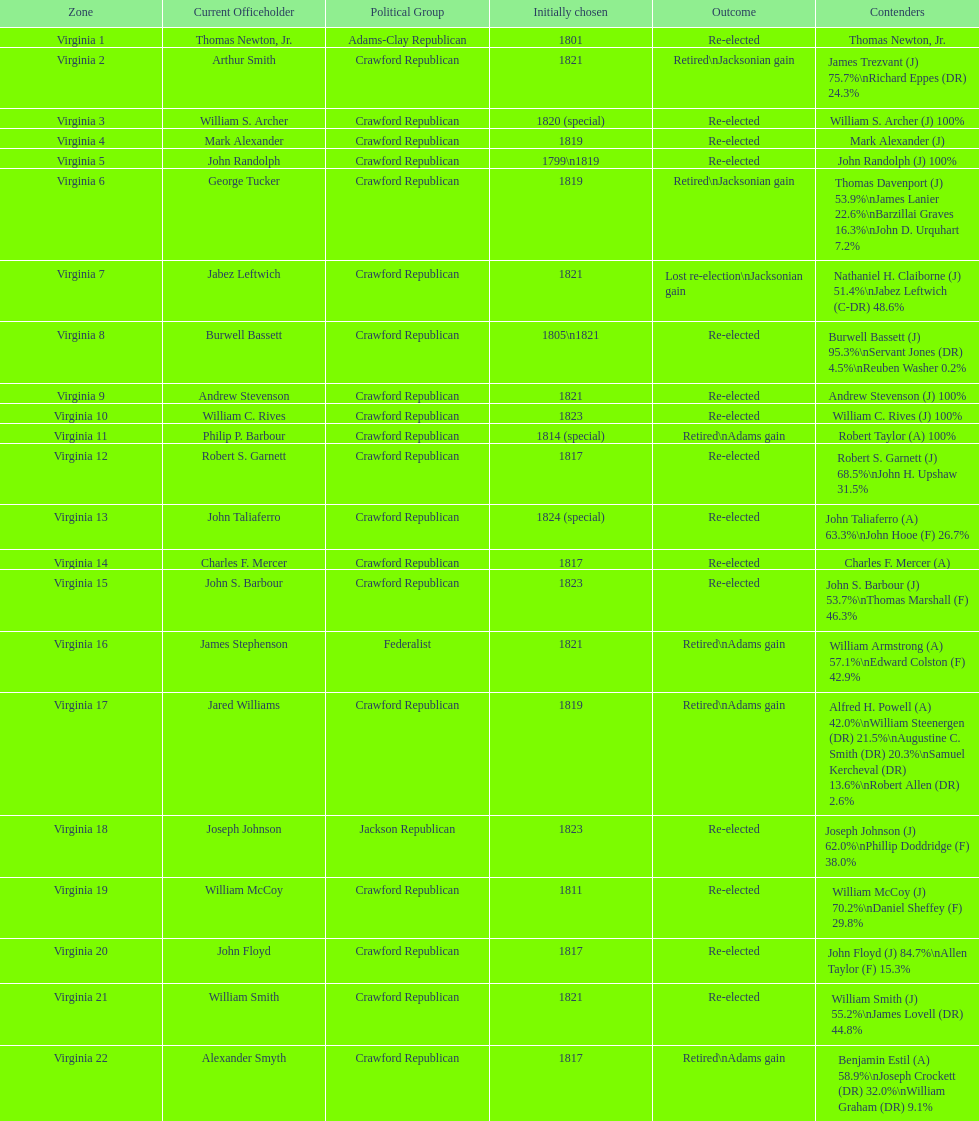Number of incumbents who retired or lost re-election 7. 